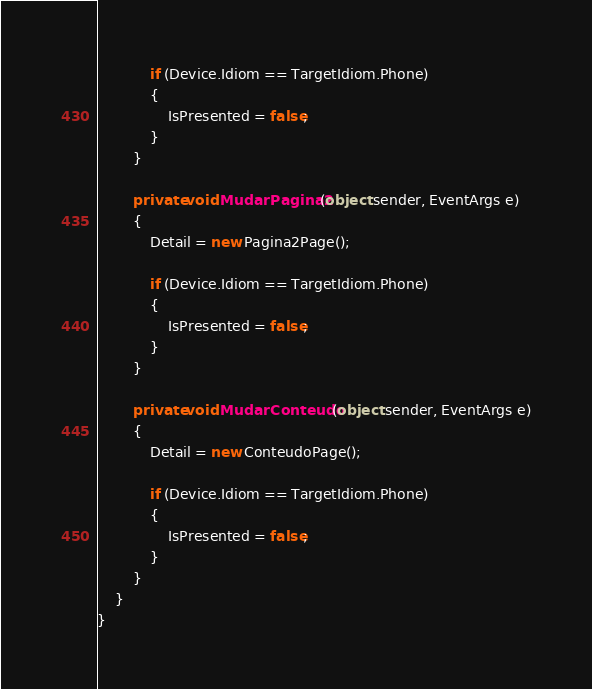<code> <loc_0><loc_0><loc_500><loc_500><_C#_>            if (Device.Idiom == TargetIdiom.Phone)
            {
                IsPresented = false;
            }
        }

        private void MudarPagina2(object sender, EventArgs e)
        {
            Detail = new Pagina2Page();

            if (Device.Idiom == TargetIdiom.Phone)
            {
                IsPresented = false;
            }
        }

        private void MudarConteudo(object sender, EventArgs e)
        {
            Detail = new ConteudoPage();

            if (Device.Idiom == TargetIdiom.Phone)
            {
                IsPresented = false;
            }
        }
    }
}
</code> 